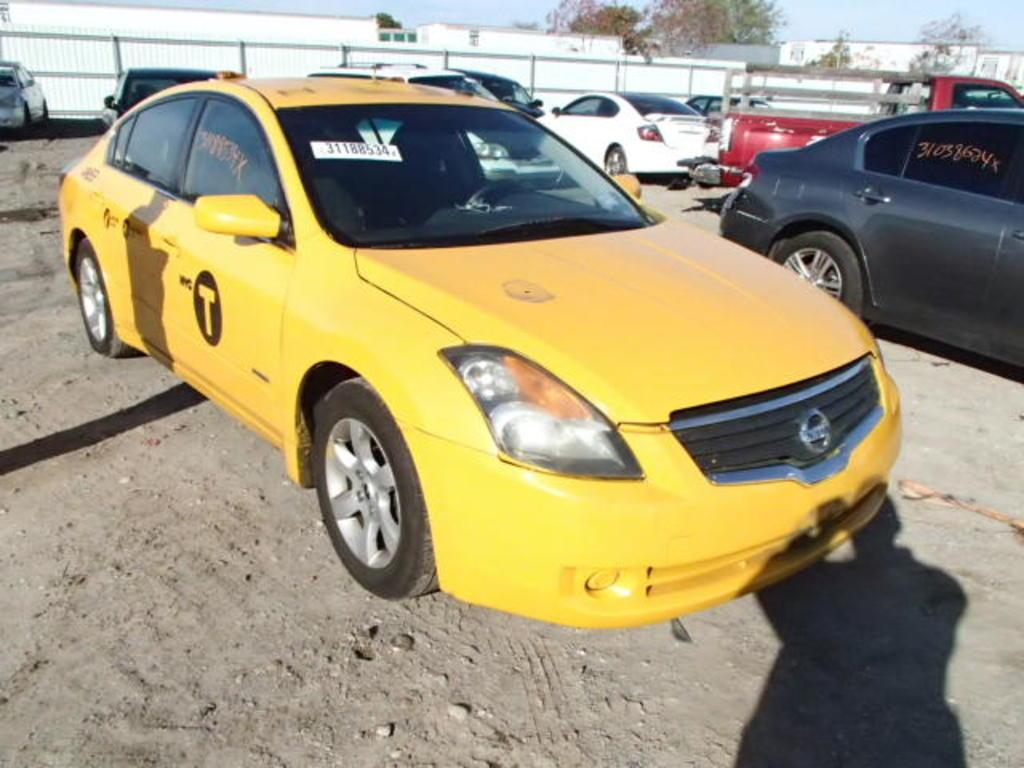Provide a one-sentence caption for the provided image. A New York yellow taxi cab numbered 31188534. 